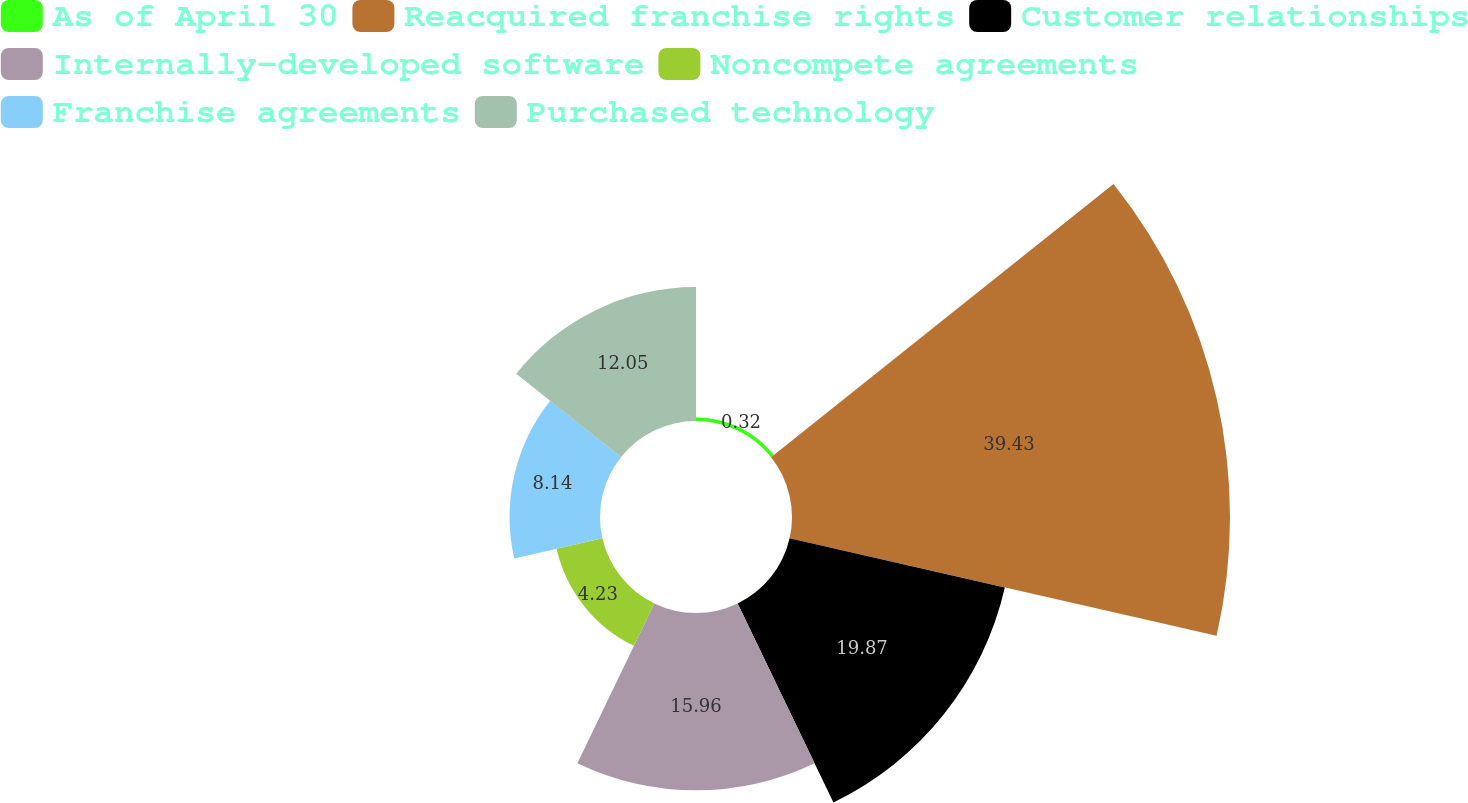Convert chart. <chart><loc_0><loc_0><loc_500><loc_500><pie_chart><fcel>As of April 30<fcel>Reacquired franchise rights<fcel>Customer relationships<fcel>Internally-developed software<fcel>Noncompete agreements<fcel>Franchise agreements<fcel>Purchased technology<nl><fcel>0.32%<fcel>39.42%<fcel>19.87%<fcel>15.96%<fcel>4.23%<fcel>8.14%<fcel>12.05%<nl></chart> 